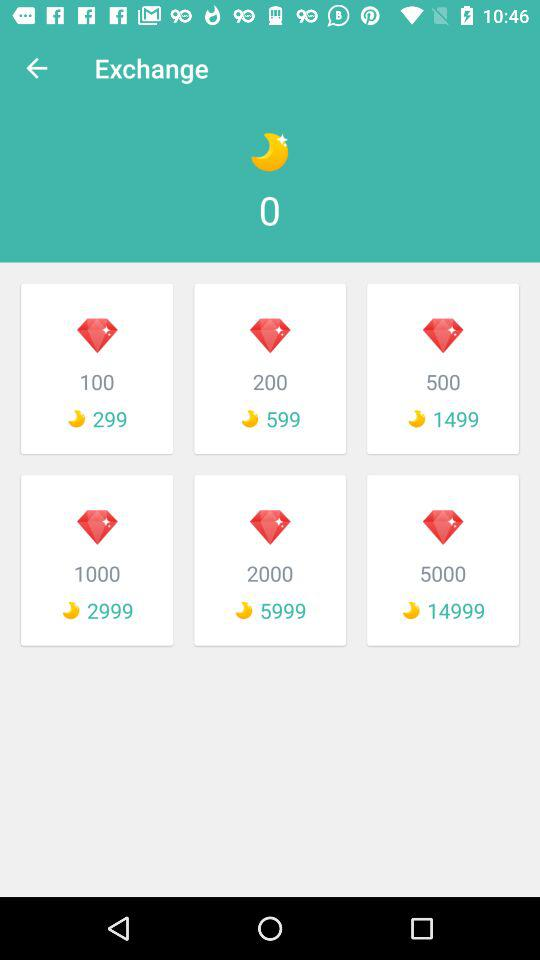What is the exchange value of 2000 diamonds? The exchange value of 2000 diamonds is 5999. 